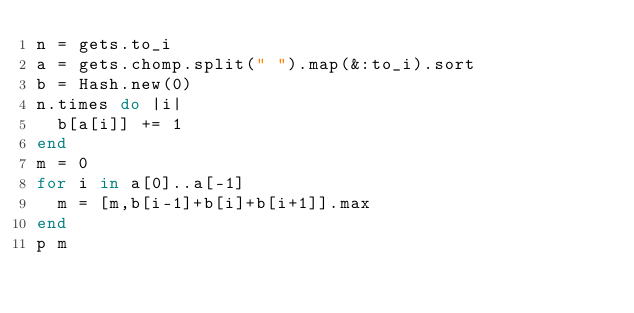Convert code to text. <code><loc_0><loc_0><loc_500><loc_500><_Ruby_>n = gets.to_i
a = gets.chomp.split(" ").map(&:to_i).sort
b = Hash.new(0)
n.times do |i|
  b[a[i]] += 1
end
m = 0
for i in a[0]..a[-1]
  m = [m,b[i-1]+b[i]+b[i+1]].max
end
p m</code> 